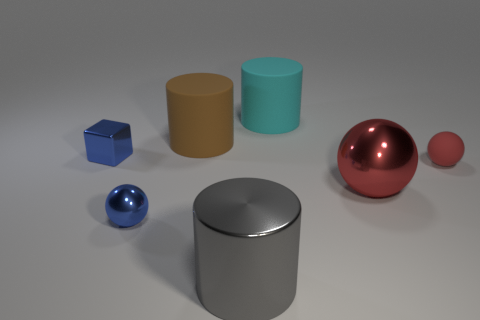Add 2 large metal objects. How many objects exist? 9 Subtract all large matte cylinders. How many cylinders are left? 1 Subtract all cylinders. How many objects are left? 4 Add 7 blue objects. How many blue objects are left? 9 Add 6 large blue metallic cylinders. How many large blue metallic cylinders exist? 6 Subtract all cyan cylinders. How many cylinders are left? 2 Subtract 0 blue cylinders. How many objects are left? 7 Subtract 1 balls. How many balls are left? 2 Subtract all brown cylinders. Subtract all brown spheres. How many cylinders are left? 2 Subtract all purple balls. How many gray cylinders are left? 1 